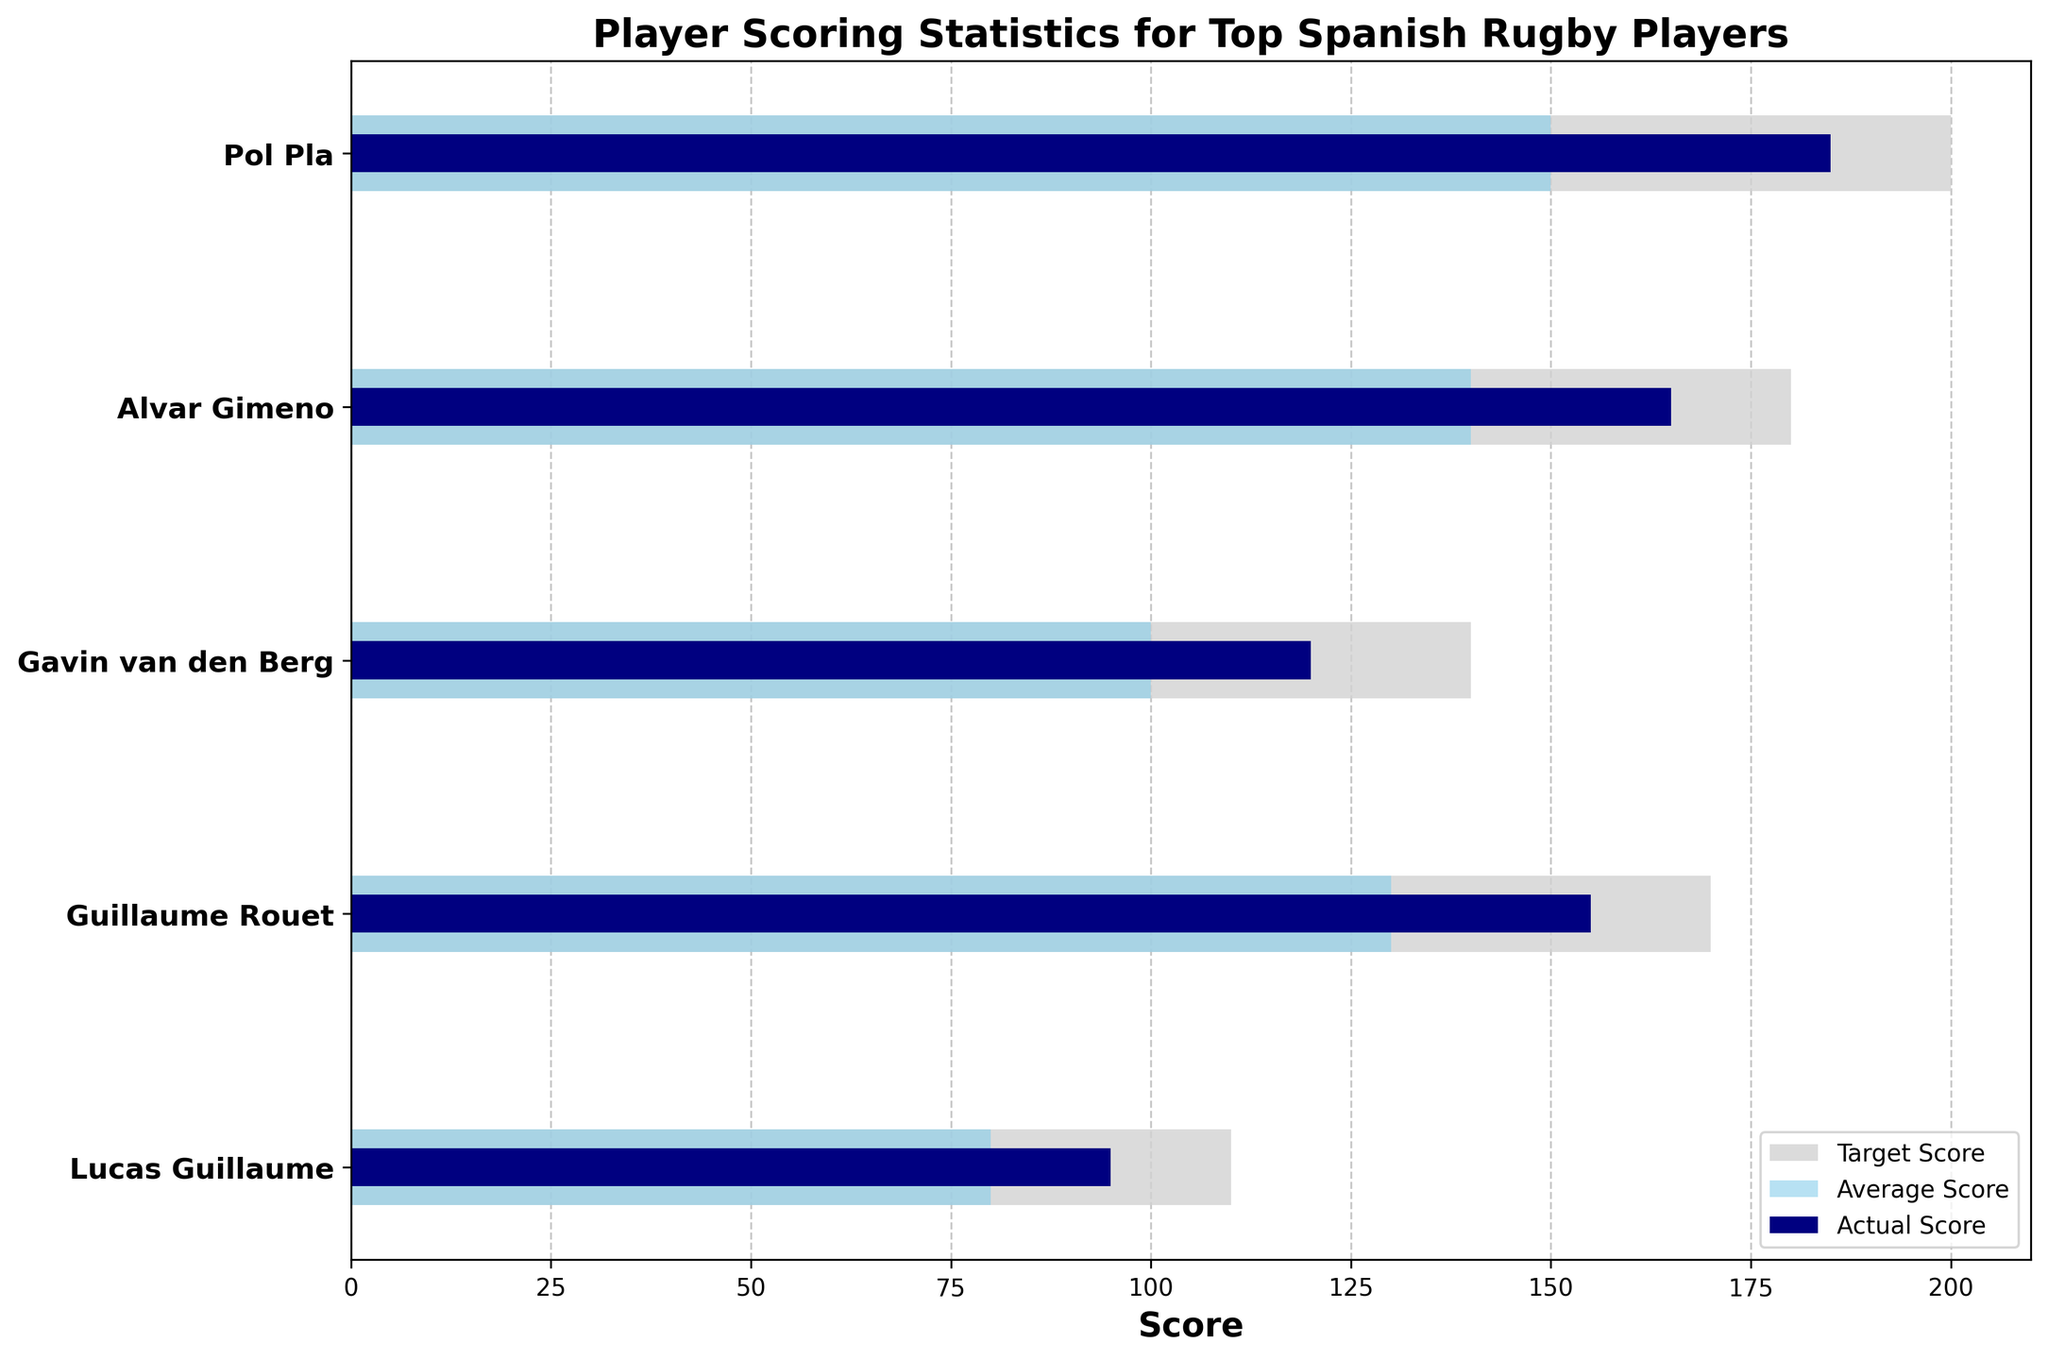What's the title of the chart? The title of a chart is typically located at the top and provides a brief description of what the chart represents. In this case, the title is "Player Scoring Statistics for Top Spanish Rugby Players."
Answer: Player Scoring Statistics for Top Spanish Rugby Players How many players are represented in the chart? The number of players can be determined by counting the number of horizontal bars displayed on the chart. Here, there are five horizontal bars, which corresponds to five players.
Answer: 5 Which player has the highest actual score? The actual scores are represented by the darkest bars on the chart. By visually comparing these bars, Pol Pla has the longest dark bar, indicating he has the highest actual score.
Answer: Pol Pla How does Lucas Guillaume's actual score compare to his target score? Lucas Guillaume's actual score is represented by the darkest bar and his target score by the lightest bar. By comparing these bars, Lucas Guillaume's actual score (shorter bar) is below his target score (longer bar).
Answer: Below What is the difference between Alvar Gimeno's actual score and the league average score for his position? Alvar Gimeno's actual score is represented by the darkest bar, and the league average is the middle-shaded bar. The difference is 165 (actual) - 140 (average) = 25.
Answer: 25 Which player exceeds their target score the most? To determine this, we compare the length of the darkest bar (actual score) and the lightest bar (target score) for each player. Pol Pla is the only player whose dark bar (185) exceeds the target (200), so he exceeds it the most.
Answer: None Who has the smallest gap between their average score and actual score? The gap between average score (middle bar) and actual score (darkest bar) can be found by calculating the difference for each player. Guillaume Rouet has the smallest gap: 155 (actual) - 130 (average) = 25.
Answer: Guillaume Rouet What is the total sum of the actual scores of all players? The sum of the actual scores of all players is calculated by adding them up: 185 (Pol Pla) + 165 (Alvar Gimeno) + 120 (Gavin van den Berg) + 155 (Guillaume Rouet) + 95 (Lucas Guillaume) = 720.
Answer: 720 Which player's actual score is closest to their average score? By comparing the differences between the actual scores and average scores for all players, the smallest difference is for Alvar Gimeno: 165 (actual) - 140 (average) = 25.
Answer: Alvar Gimeno 